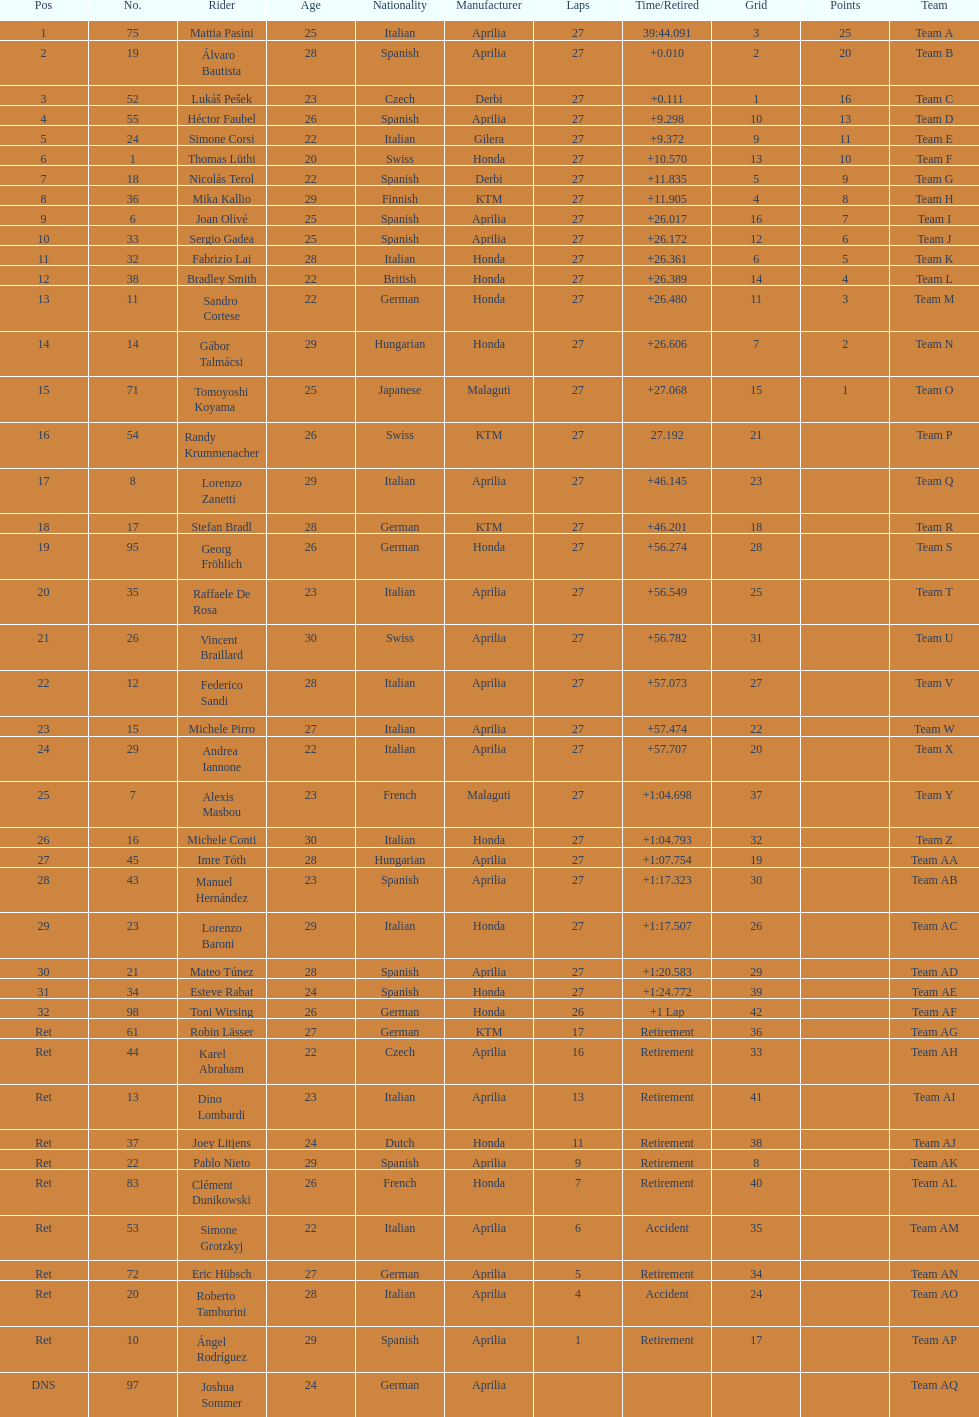Who placed higher, bradl or gadea? Sergio Gadea. 